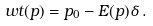Convert formula to latex. <formula><loc_0><loc_0><loc_500><loc_500>\ w t ( p ) = p _ { 0 } - E ( p ) \delta \, .</formula> 